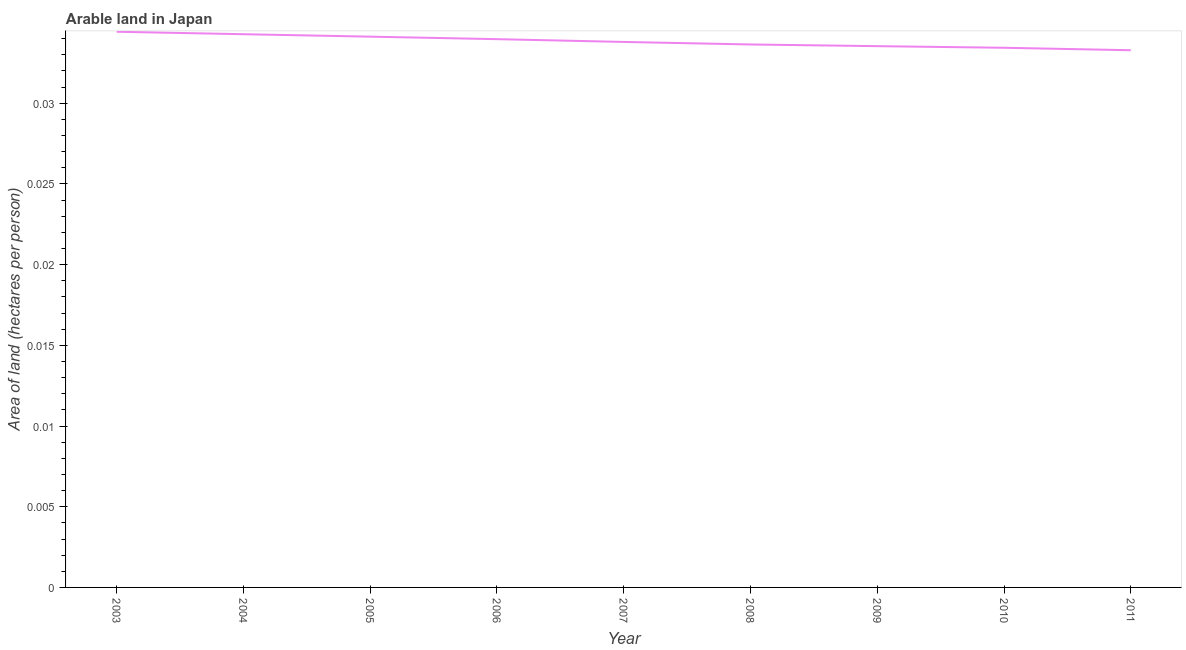What is the area of arable land in 2003?
Ensure brevity in your answer.  0.03. Across all years, what is the maximum area of arable land?
Keep it short and to the point. 0.03. Across all years, what is the minimum area of arable land?
Provide a short and direct response. 0.03. What is the sum of the area of arable land?
Ensure brevity in your answer.  0.3. What is the difference between the area of arable land in 2005 and 2007?
Your answer should be compact. 0. What is the average area of arable land per year?
Offer a very short reply. 0.03. What is the median area of arable land?
Your response must be concise. 0.03. In how many years, is the area of arable land greater than 0.01 hectares per person?
Offer a terse response. 9. Do a majority of the years between 2004 and 2011 (inclusive) have area of arable land greater than 0.002 hectares per person?
Your answer should be very brief. Yes. What is the ratio of the area of arable land in 2007 to that in 2008?
Provide a succinct answer. 1. What is the difference between the highest and the second highest area of arable land?
Your answer should be very brief. 0. Is the sum of the area of arable land in 2005 and 2009 greater than the maximum area of arable land across all years?
Ensure brevity in your answer.  Yes. What is the difference between the highest and the lowest area of arable land?
Ensure brevity in your answer.  0. In how many years, is the area of arable land greater than the average area of arable land taken over all years?
Keep it short and to the point. 4. What is the difference between two consecutive major ticks on the Y-axis?
Offer a very short reply. 0.01. What is the title of the graph?
Your answer should be very brief. Arable land in Japan. What is the label or title of the Y-axis?
Make the answer very short. Area of land (hectares per person). What is the Area of land (hectares per person) of 2003?
Ensure brevity in your answer.  0.03. What is the Area of land (hectares per person) of 2004?
Your response must be concise. 0.03. What is the Area of land (hectares per person) in 2005?
Keep it short and to the point. 0.03. What is the Area of land (hectares per person) in 2006?
Keep it short and to the point. 0.03. What is the Area of land (hectares per person) in 2007?
Your answer should be compact. 0.03. What is the Area of land (hectares per person) of 2008?
Give a very brief answer. 0.03. What is the Area of land (hectares per person) in 2009?
Your answer should be very brief. 0.03. What is the Area of land (hectares per person) in 2010?
Your answer should be very brief. 0.03. What is the Area of land (hectares per person) in 2011?
Your response must be concise. 0.03. What is the difference between the Area of land (hectares per person) in 2003 and 2004?
Offer a terse response. 0. What is the difference between the Area of land (hectares per person) in 2003 and 2005?
Offer a terse response. 0. What is the difference between the Area of land (hectares per person) in 2003 and 2006?
Your answer should be very brief. 0. What is the difference between the Area of land (hectares per person) in 2003 and 2007?
Ensure brevity in your answer.  0. What is the difference between the Area of land (hectares per person) in 2003 and 2008?
Ensure brevity in your answer.  0. What is the difference between the Area of land (hectares per person) in 2003 and 2009?
Keep it short and to the point. 0. What is the difference between the Area of land (hectares per person) in 2003 and 2010?
Ensure brevity in your answer.  0. What is the difference between the Area of land (hectares per person) in 2003 and 2011?
Give a very brief answer. 0. What is the difference between the Area of land (hectares per person) in 2004 and 2005?
Make the answer very short. 0. What is the difference between the Area of land (hectares per person) in 2004 and 2006?
Ensure brevity in your answer.  0. What is the difference between the Area of land (hectares per person) in 2004 and 2007?
Offer a terse response. 0. What is the difference between the Area of land (hectares per person) in 2004 and 2008?
Make the answer very short. 0. What is the difference between the Area of land (hectares per person) in 2004 and 2009?
Ensure brevity in your answer.  0. What is the difference between the Area of land (hectares per person) in 2004 and 2010?
Provide a short and direct response. 0. What is the difference between the Area of land (hectares per person) in 2004 and 2011?
Your response must be concise. 0. What is the difference between the Area of land (hectares per person) in 2005 and 2006?
Make the answer very short. 0. What is the difference between the Area of land (hectares per person) in 2005 and 2007?
Offer a terse response. 0. What is the difference between the Area of land (hectares per person) in 2005 and 2008?
Give a very brief answer. 0. What is the difference between the Area of land (hectares per person) in 2005 and 2009?
Make the answer very short. 0. What is the difference between the Area of land (hectares per person) in 2005 and 2010?
Your answer should be compact. 0. What is the difference between the Area of land (hectares per person) in 2005 and 2011?
Provide a short and direct response. 0. What is the difference between the Area of land (hectares per person) in 2006 and 2007?
Ensure brevity in your answer.  0. What is the difference between the Area of land (hectares per person) in 2006 and 2008?
Provide a short and direct response. 0. What is the difference between the Area of land (hectares per person) in 2006 and 2009?
Your answer should be very brief. 0. What is the difference between the Area of land (hectares per person) in 2006 and 2010?
Offer a terse response. 0. What is the difference between the Area of land (hectares per person) in 2006 and 2011?
Your answer should be very brief. 0. What is the difference between the Area of land (hectares per person) in 2007 and 2008?
Provide a succinct answer. 0. What is the difference between the Area of land (hectares per person) in 2007 and 2009?
Keep it short and to the point. 0. What is the difference between the Area of land (hectares per person) in 2007 and 2010?
Your answer should be compact. 0. What is the difference between the Area of land (hectares per person) in 2007 and 2011?
Your answer should be compact. 0. What is the difference between the Area of land (hectares per person) in 2008 and 2009?
Your response must be concise. 0. What is the difference between the Area of land (hectares per person) in 2008 and 2010?
Your answer should be very brief. 0. What is the difference between the Area of land (hectares per person) in 2008 and 2011?
Your response must be concise. 0. What is the difference between the Area of land (hectares per person) in 2009 and 2011?
Provide a succinct answer. 0. What is the difference between the Area of land (hectares per person) in 2010 and 2011?
Provide a short and direct response. 0. What is the ratio of the Area of land (hectares per person) in 2003 to that in 2007?
Your answer should be compact. 1.02. What is the ratio of the Area of land (hectares per person) in 2003 to that in 2008?
Give a very brief answer. 1.02. What is the ratio of the Area of land (hectares per person) in 2003 to that in 2009?
Offer a terse response. 1.03. What is the ratio of the Area of land (hectares per person) in 2003 to that in 2011?
Make the answer very short. 1.03. What is the ratio of the Area of land (hectares per person) in 2004 to that in 2005?
Your response must be concise. 1. What is the ratio of the Area of land (hectares per person) in 2004 to that in 2008?
Provide a short and direct response. 1.02. What is the ratio of the Area of land (hectares per person) in 2004 to that in 2010?
Provide a short and direct response. 1.02. What is the ratio of the Area of land (hectares per person) in 2004 to that in 2011?
Provide a short and direct response. 1.03. What is the ratio of the Area of land (hectares per person) in 2005 to that in 2010?
Your answer should be compact. 1.02. What is the ratio of the Area of land (hectares per person) in 2006 to that in 2008?
Provide a short and direct response. 1.01. What is the ratio of the Area of land (hectares per person) in 2006 to that in 2010?
Give a very brief answer. 1.02. What is the ratio of the Area of land (hectares per person) in 2007 to that in 2008?
Provide a short and direct response. 1. What is the ratio of the Area of land (hectares per person) in 2008 to that in 2011?
Provide a succinct answer. 1.01. What is the ratio of the Area of land (hectares per person) in 2009 to that in 2011?
Give a very brief answer. 1.01. What is the ratio of the Area of land (hectares per person) in 2010 to that in 2011?
Ensure brevity in your answer.  1. 